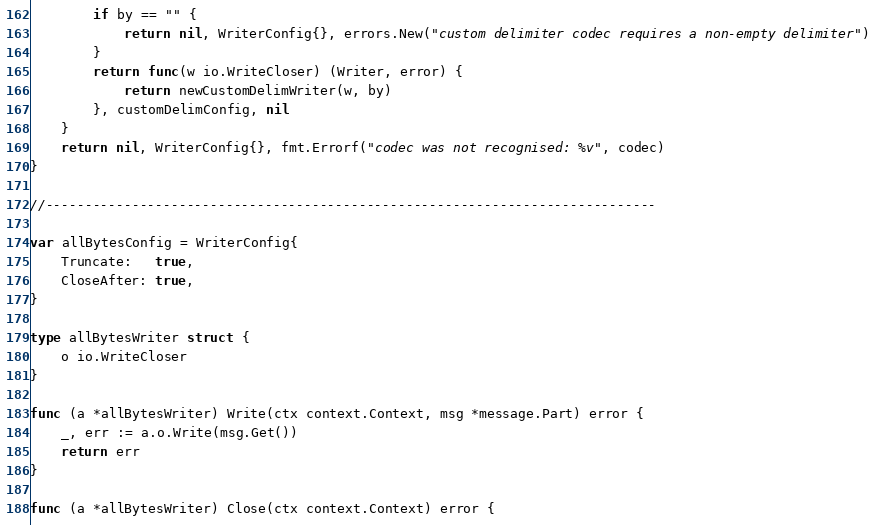Convert code to text. <code><loc_0><loc_0><loc_500><loc_500><_Go_>		if by == "" {
			return nil, WriterConfig{}, errors.New("custom delimiter codec requires a non-empty delimiter")
		}
		return func(w io.WriteCloser) (Writer, error) {
			return newCustomDelimWriter(w, by)
		}, customDelimConfig, nil
	}
	return nil, WriterConfig{}, fmt.Errorf("codec was not recognised: %v", codec)
}

//------------------------------------------------------------------------------

var allBytesConfig = WriterConfig{
	Truncate:   true,
	CloseAfter: true,
}

type allBytesWriter struct {
	o io.WriteCloser
}

func (a *allBytesWriter) Write(ctx context.Context, msg *message.Part) error {
	_, err := a.o.Write(msg.Get())
	return err
}

func (a *allBytesWriter) Close(ctx context.Context) error {</code> 